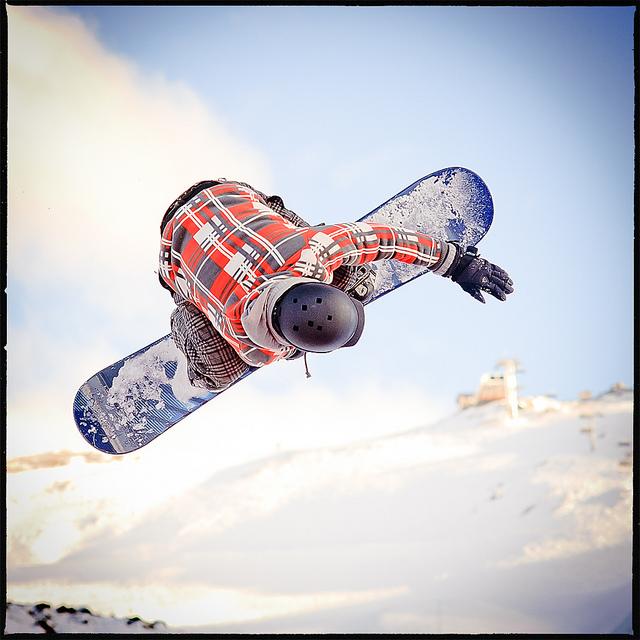Is the man an Acrobat?
Keep it brief. No. What winter sport is happening?
Answer briefly. Snowboarding. Will the man get hurt?
Give a very brief answer. No. 